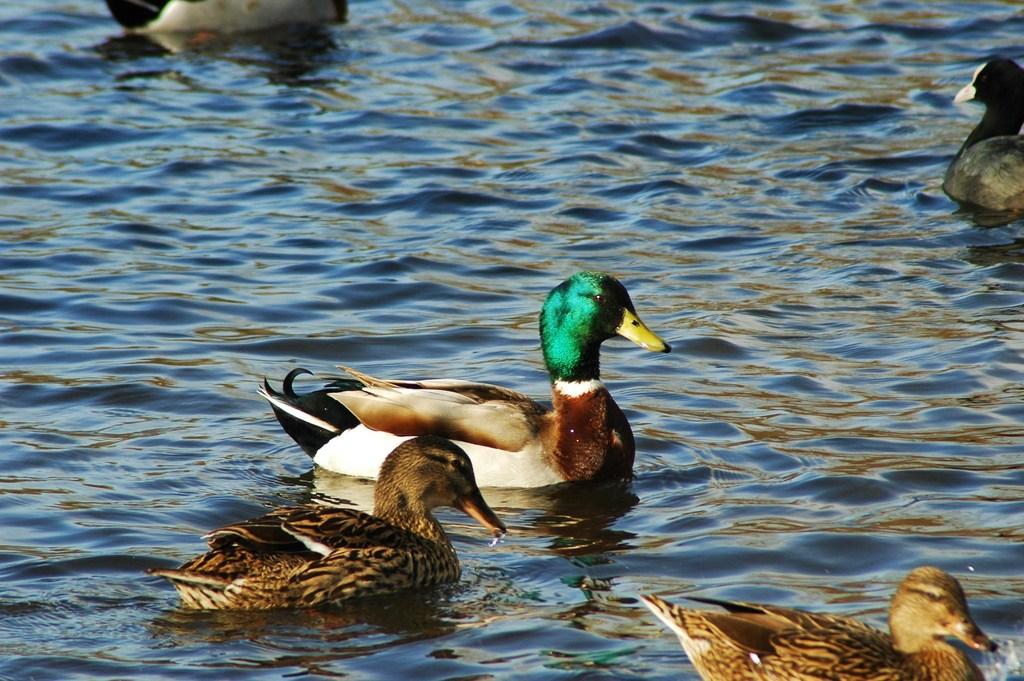Can you describe this image briefly? In this picture I can see ducks on the water. 